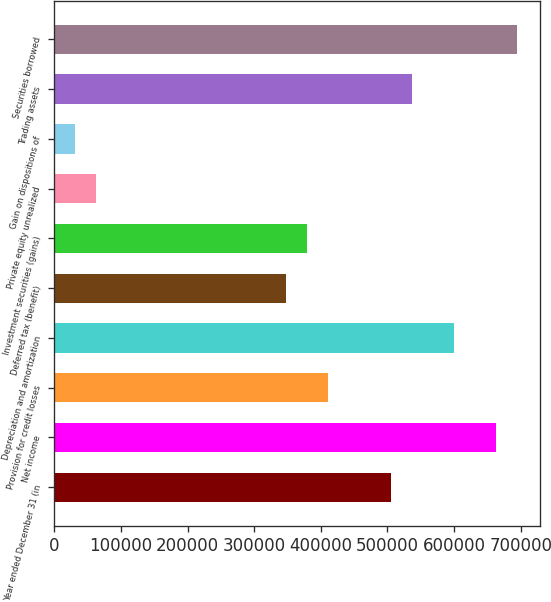Convert chart. <chart><loc_0><loc_0><loc_500><loc_500><bar_chart><fcel>Year ended December 31 (in<fcel>Net income<fcel>Provision for credit losses<fcel>Depreciation and amortization<fcel>Deferred tax (benefit)<fcel>Investment securities (gains)<fcel>Private equity unrealized<fcel>Gain on dispositions of<fcel>Trading assets<fcel>Securities borrowed<nl><fcel>505143<fcel>662980<fcel>410440<fcel>599846<fcel>347306<fcel>378873<fcel>63198<fcel>31630.5<fcel>536710<fcel>694548<nl></chart> 